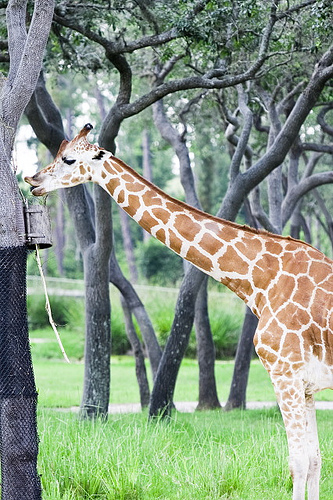<image>What is this animal eating? It is unknown what the animal is eating. It could be eating leaves or tree bark. What is this animal eating? I don't know what the animal is eating. It can be leaves or tree bark. 